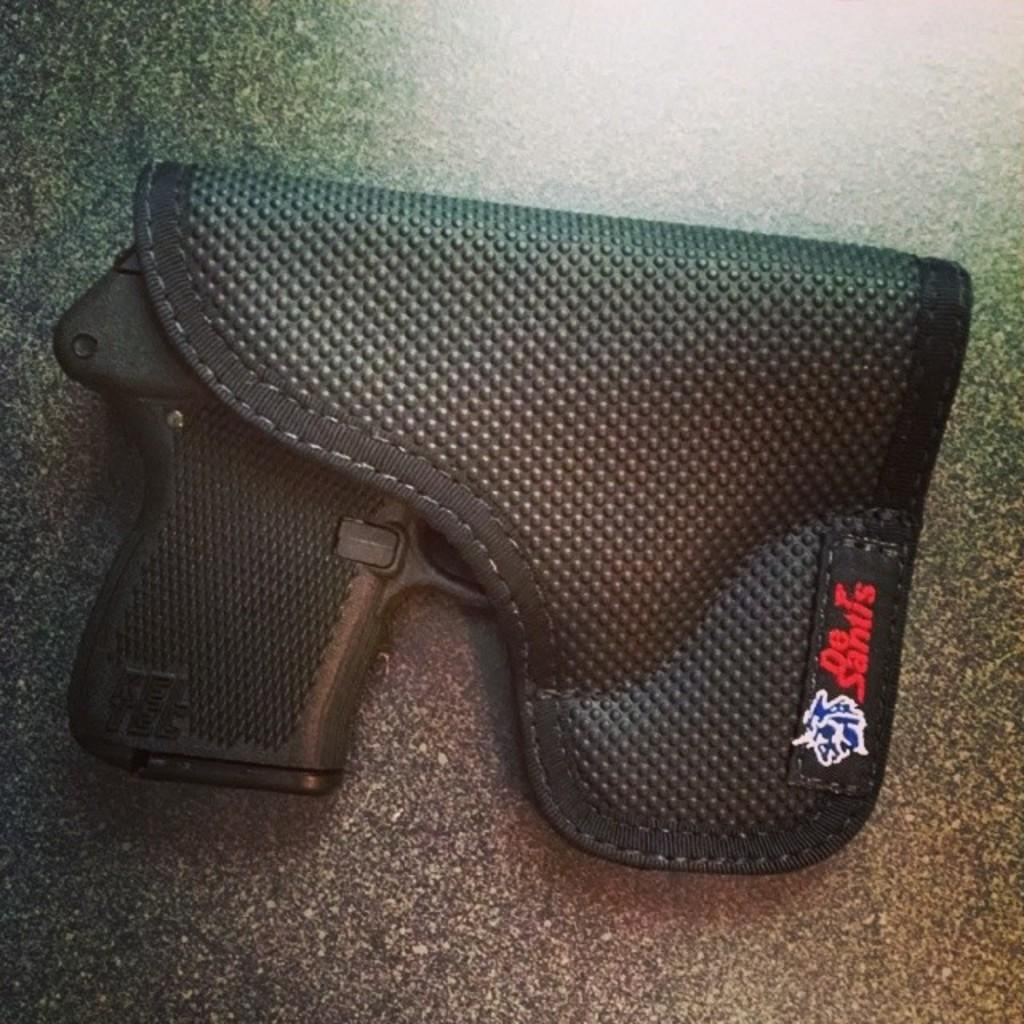What object is present in the image that is typically used as a weapon? There is a gun in the image. How is the gun being stored or displayed in the image? The gun is placed in a case. Where is the gun and case located in the image? The gun and case are on a surface. What type of sidewalk can be seen in the image? There is no sidewalk present in the image. How does the winter weather affect the appearance of the gun and case in the image? There is no reference to winter weather in the image, so it cannot be determined how it might affect the appearance of the gun and case. 